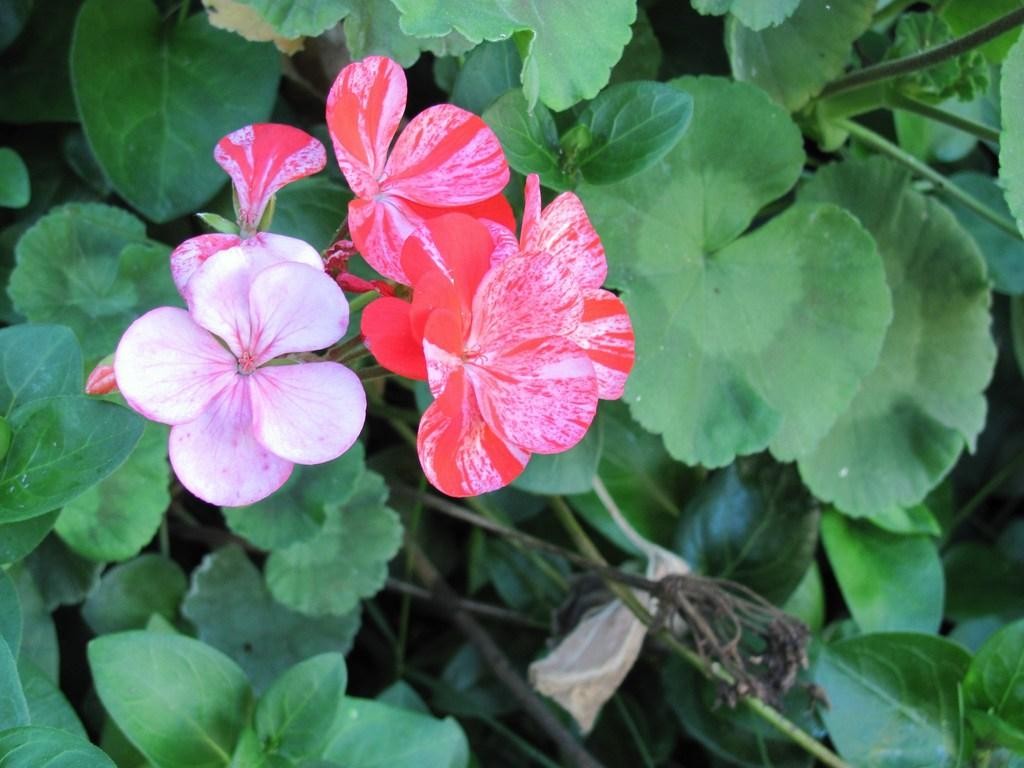What type of living organisms can be seen in the image? Flowers and plants are visible in the image. Can you describe the plants in the image? The plants in the image are not specified, but they are present alongside the flowers. How many times do the people in the image kiss each other? There are no people present in the image, so it is not possible to determine how many times they might kiss each other. 